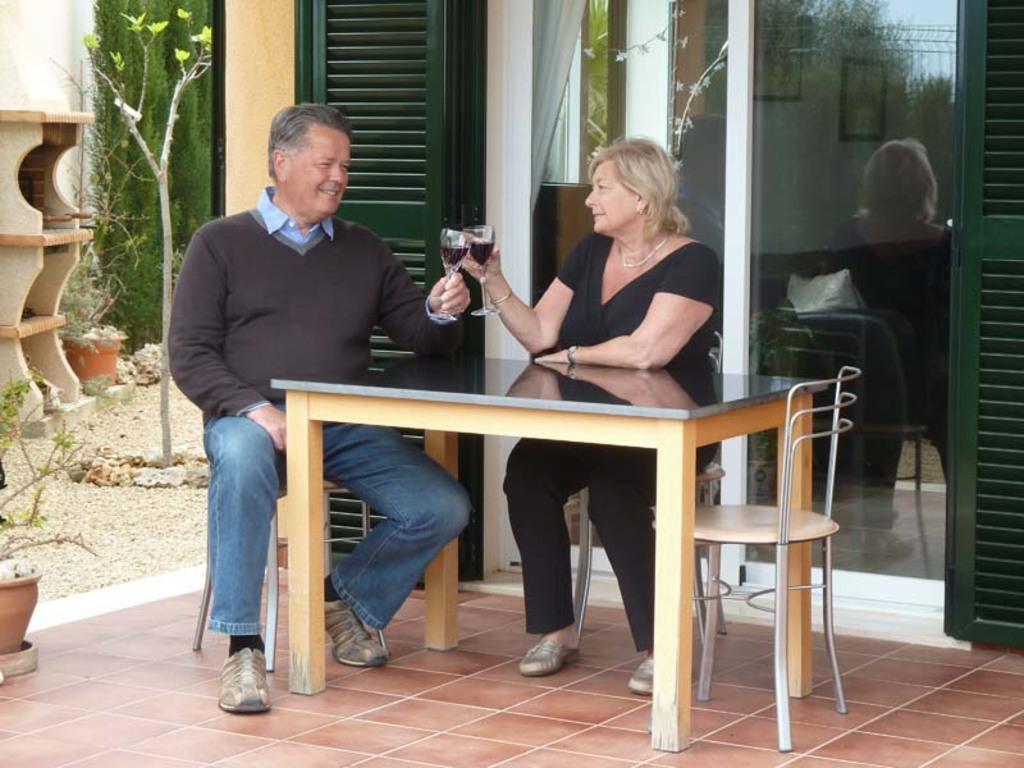How would you summarize this image in a sentence or two? In the center we can see two persons were sitting on the chair around the table. And they were holding two wine glasses. In the background we can see plant,tree,flower pot,sand,door,glass and curtain. 